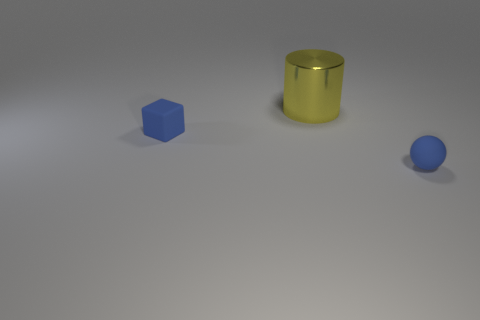What number of matte objects have the same color as the metal cylinder?
Your response must be concise. 0. What number of other objects are the same color as the large cylinder?
Provide a short and direct response. 0. Are there more big yellow objects than small rubber objects?
Provide a succinct answer. No. What is the material of the cylinder?
Provide a short and direct response. Metal. Does the metal object that is on the right side of the blue block have the same size as the small blue cube?
Offer a very short reply. No. How big is the object behind the blue cube?
Give a very brief answer. Large. Are there any other things that have the same material as the blue block?
Provide a succinct answer. Yes. How many yellow metal balls are there?
Offer a very short reply. 0. Do the tiny rubber sphere and the rubber cube have the same color?
Offer a terse response. Yes. What is the color of the thing that is to the right of the tiny blue block and left of the blue sphere?
Provide a succinct answer. Yellow. 